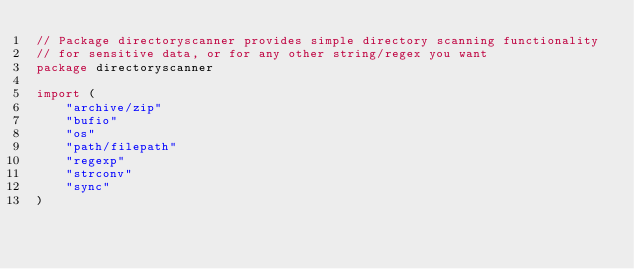Convert code to text. <code><loc_0><loc_0><loc_500><loc_500><_Go_>// Package directoryscanner provides simple directory scanning functionality
// for sensitive data, or for any other string/regex you want
package directoryscanner

import (
	"archive/zip"
	"bufio"
	"os"
	"path/filepath"
	"regexp"
	"strconv"
	"sync"
)
</code> 